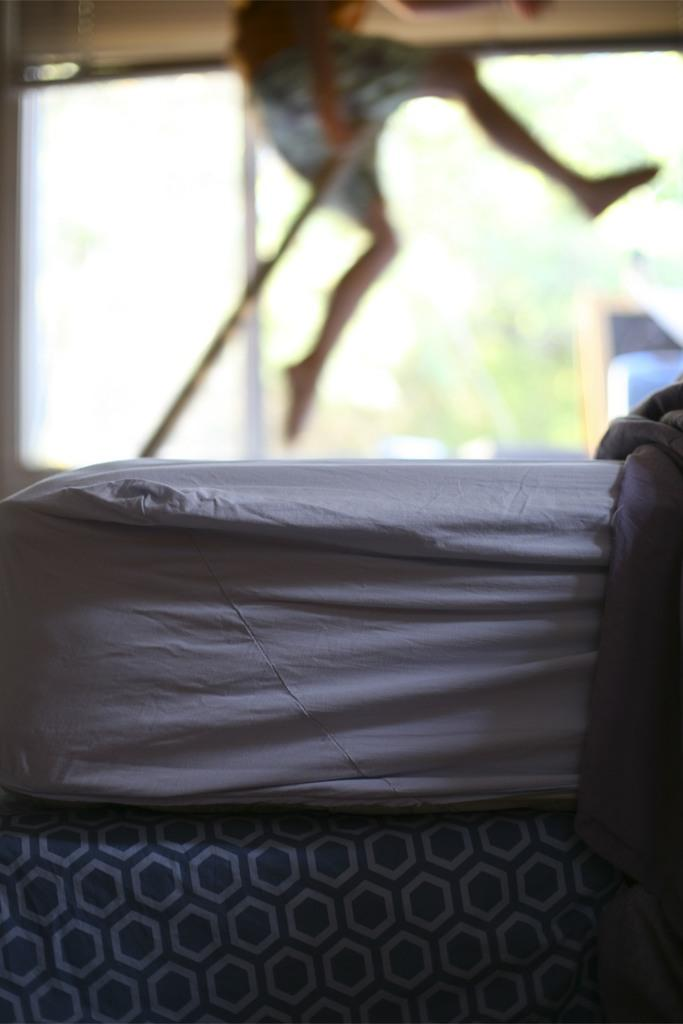What is the main object in the center of the image? There is a bed in the center of the image. What can be seen in the background of the image? There is a man in the background of the image, and he is jumping. What architectural feature is present in the background of the image? There is a window in the background of the image. How many deer are visible in the image? There are no deer present in the image. What type of bun is being used as a pillow on the bed? There is no bun present on the bed in the image. 